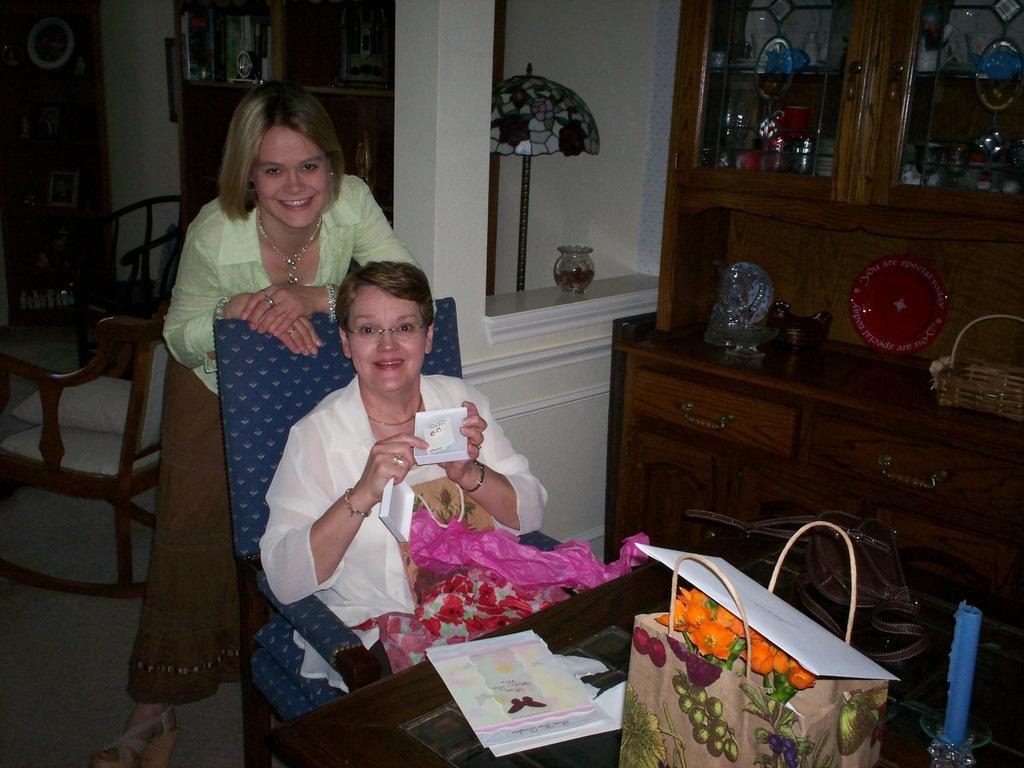In one or two sentences, can you explain what this image depicts? In this picture I can see there are two women, one of them is sitting in the chair and the other is standing behind her. They are smiling, the woman who is sitting is holding a box, there are a few covers with her. There is a table in front of her. I can see there are few papers, a candle with a stand and there is a candle stand. There is a wooden shelf at right side, there is crockery arranged. In the backdrop, I can see there are a few chairs and a lamp. 